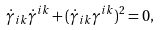<formula> <loc_0><loc_0><loc_500><loc_500>\dot { \gamma } _ { i k } \dot { \gamma } ^ { i k } + ( \dot { \gamma } _ { i k } \gamma ^ { i k } ) ^ { 2 } = 0 ,</formula> 